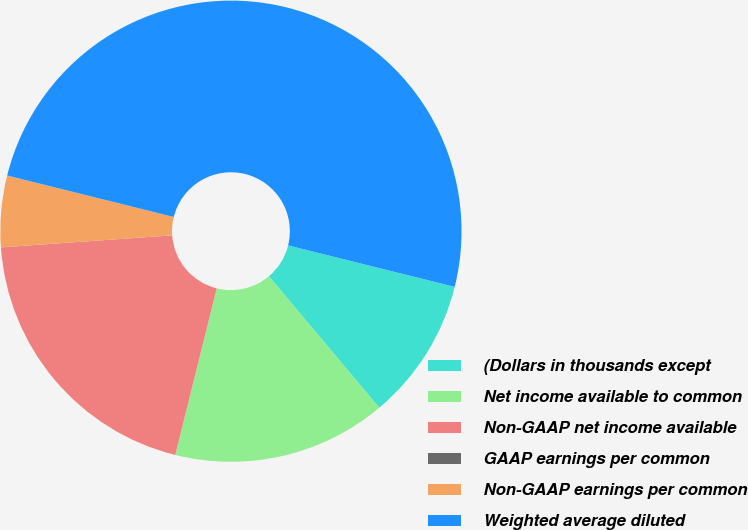Convert chart. <chart><loc_0><loc_0><loc_500><loc_500><pie_chart><fcel>(Dollars in thousands except<fcel>Net income available to common<fcel>Non-GAAP net income available<fcel>GAAP earnings per common<fcel>Non-GAAP earnings per common<fcel>Weighted average diluted<nl><fcel>10.0%<fcel>15.0%<fcel>20.0%<fcel>0.0%<fcel>5.0%<fcel>50.0%<nl></chart> 